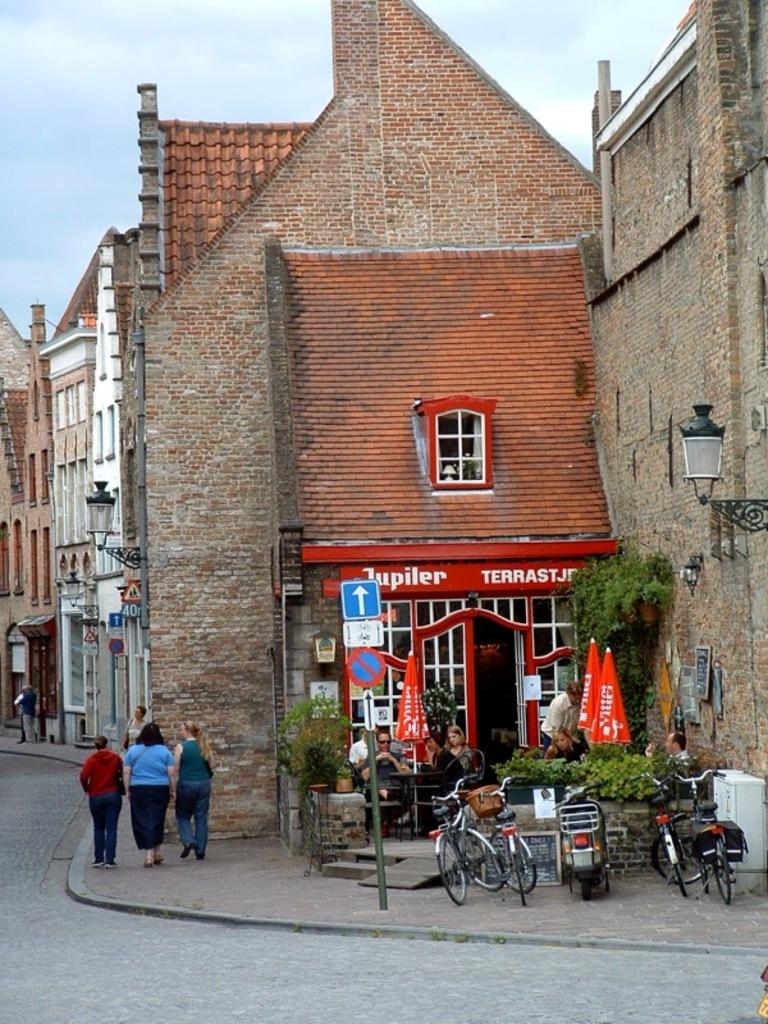<image>
Relay a brief, clear account of the picture shown. The name of the store in the background is called Jupiler 